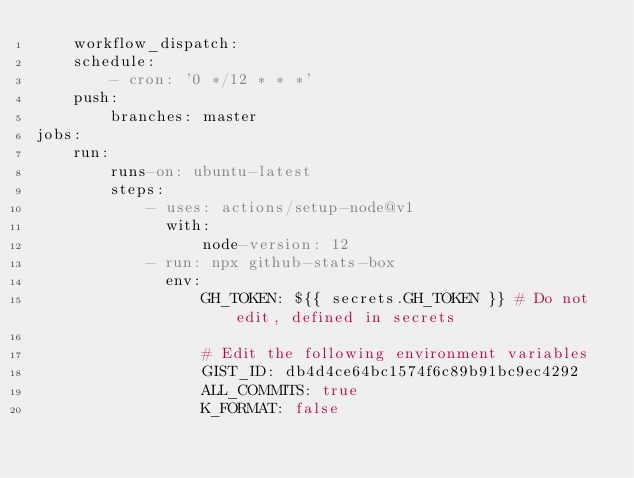Convert code to text. <code><loc_0><loc_0><loc_500><loc_500><_YAML_>    workflow_dispatch:
    schedule:
        - cron: '0 */12 * * *'
    push:
        branches: master
jobs:
    run:
        runs-on: ubuntu-latest
        steps:
            - uses: actions/setup-node@v1
              with:
                  node-version: 12
            - run: npx github-stats-box
              env:
                  GH_TOKEN: ${{ secrets.GH_TOKEN }} # Do not edit, defined in secrets

                  # Edit the following environment variables
                  GIST_ID: db4d4ce64bc1574f6c89b91bc9ec4292
                  ALL_COMMITS: true
                  K_FORMAT: false
</code> 